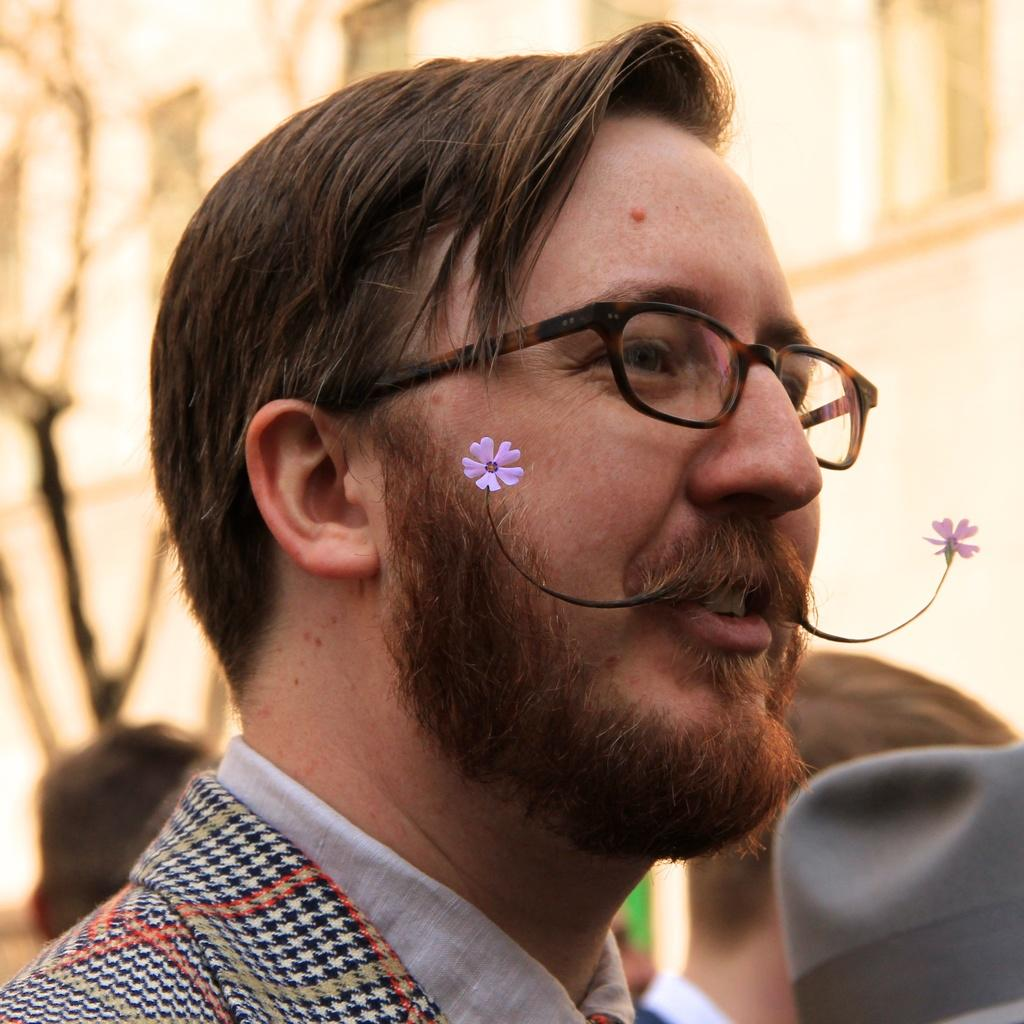Who is the main subject in the image? There is a man in the image. What accessory is the man wearing? The man is wearing glasses. What is unique about the man's mustache? There are flowers on the man's mustache. Can you describe the setting of the image? There are people visible in the background of the image. What type of food is the man eating in the image? There is no food present in the image; the man has flowers on his mustache. What is the title of the book the man is reading in the image? There is no book visible in the image, so it is not possible to determine the title. 